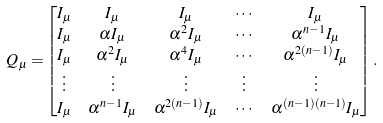Convert formula to latex. <formula><loc_0><loc_0><loc_500><loc_500>Q _ { \mu } = & \begin{bmatrix} I _ { \mu } & I _ { \mu } & I _ { \mu } & \cdots & I _ { \mu } \\ I _ { \mu } & \alpha { I _ { \mu } } & \alpha ^ { 2 } I _ { \mu } & \cdots & \alpha ^ { n - 1 } I _ { \mu } \\ I _ { \mu } & \alpha ^ { 2 } I _ { \mu } & \alpha ^ { 4 } I _ { \mu } & \cdots & \alpha ^ { 2 ( n - 1 ) } I _ { \mu } \\ \vdots & \vdots & \vdots & \vdots & \vdots \\ I _ { \mu } & \alpha ^ { n - 1 } I _ { \mu } & \alpha ^ { 2 ( n - 1 ) } I _ { \mu } & \cdots & \alpha ^ { ( n - 1 ) ( n - 1 ) } I _ { \mu } \end{bmatrix} .</formula> 